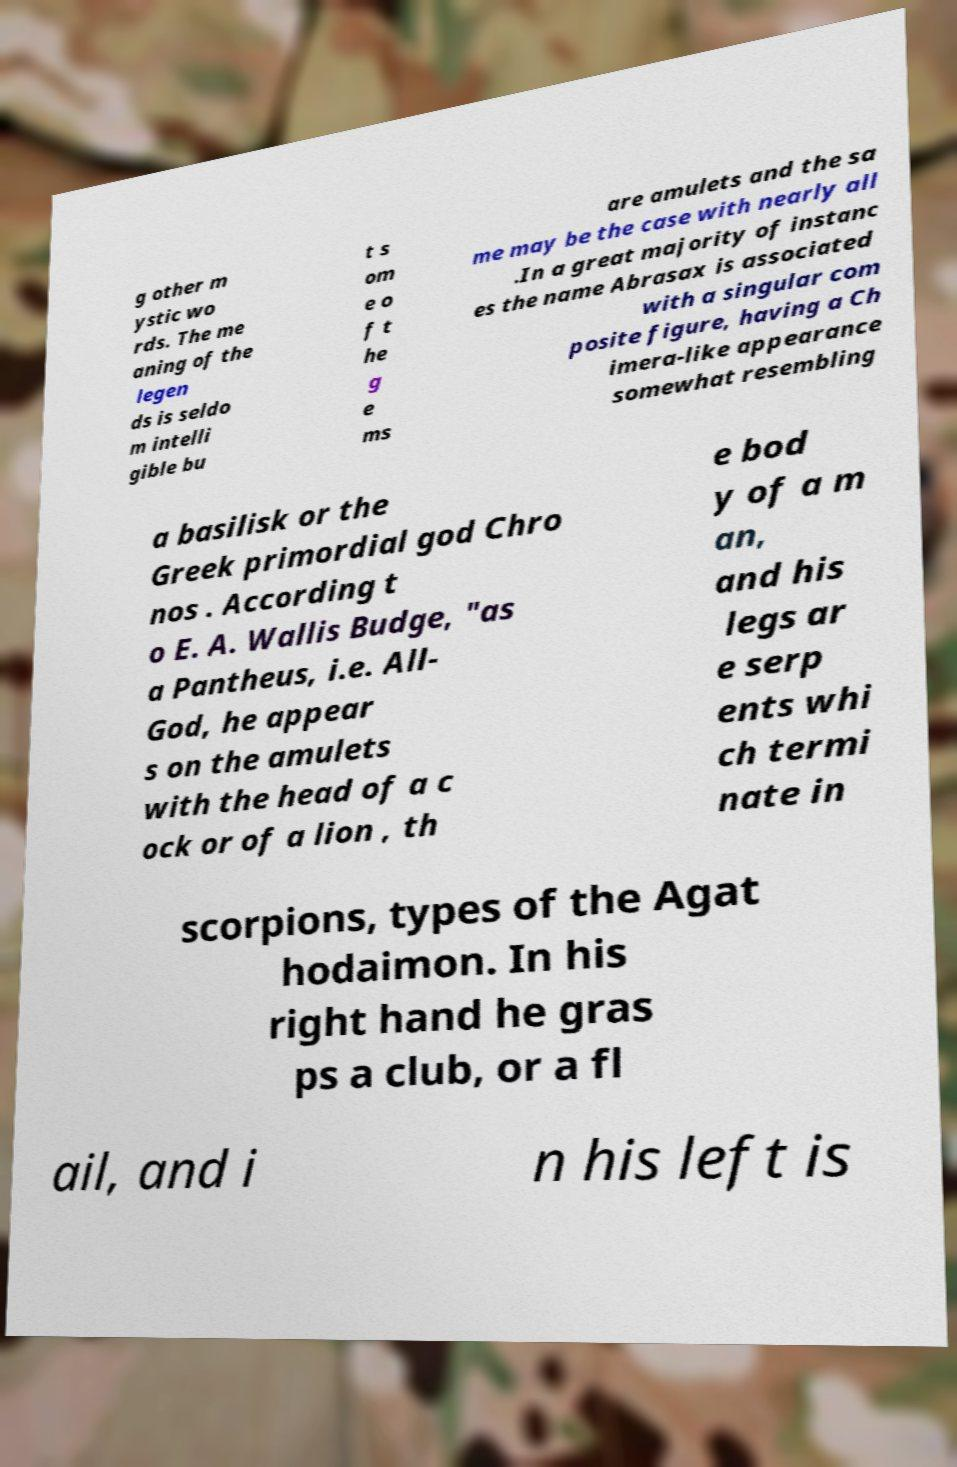Can you read and provide the text displayed in the image?This photo seems to have some interesting text. Can you extract and type it out for me? g other m ystic wo rds. The me aning of the legen ds is seldo m intelli gible bu t s om e o f t he g e ms are amulets and the sa me may be the case with nearly all .In a great majority of instanc es the name Abrasax is associated with a singular com posite figure, having a Ch imera-like appearance somewhat resembling a basilisk or the Greek primordial god Chro nos . According t o E. A. Wallis Budge, "as a Pantheus, i.e. All- God, he appear s on the amulets with the head of a c ock or of a lion , th e bod y of a m an, and his legs ar e serp ents whi ch termi nate in scorpions, types of the Agat hodaimon. In his right hand he gras ps a club, or a fl ail, and i n his left is 